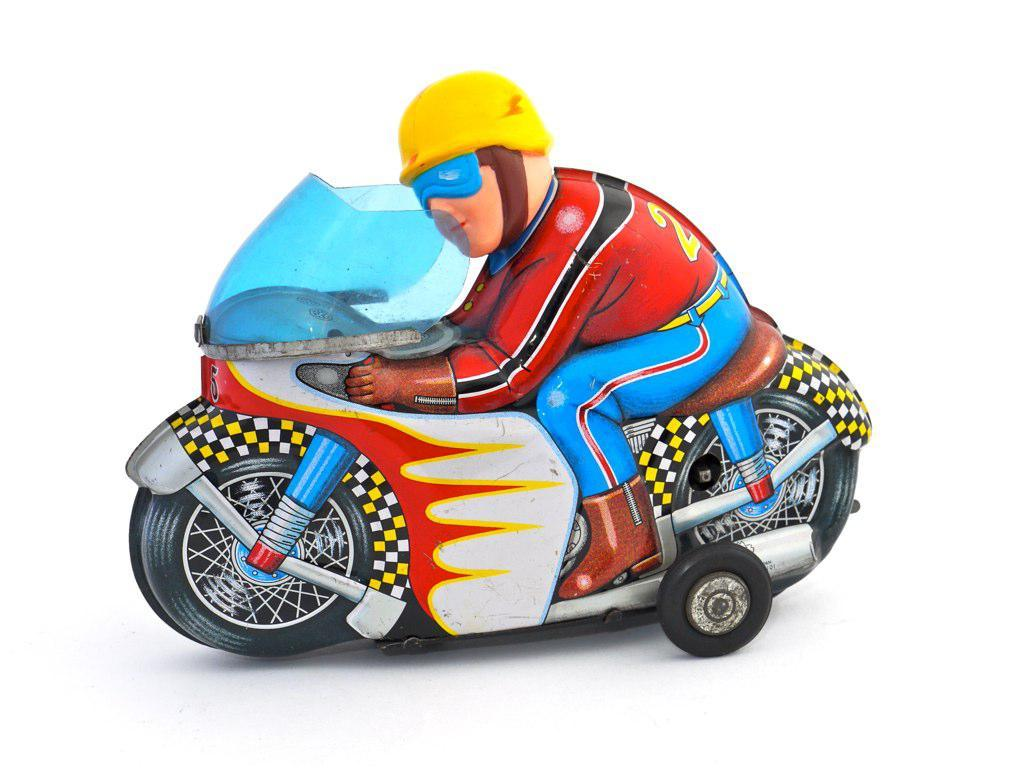What object can be seen in the image? There is a toy in the image. Can you describe the person in the image? There is a person with a yellow helmet in the image. What is the person doing in the image? The person is riding a motorbike toy. What type of rice is being cooked by the owl in the image? There is no owl or rice present in the image. How many people are in the group riding the toy motorbike in the image? There is only one person with a yellow helmet riding the toy motorbike in the image, and there is no group mentioned. 